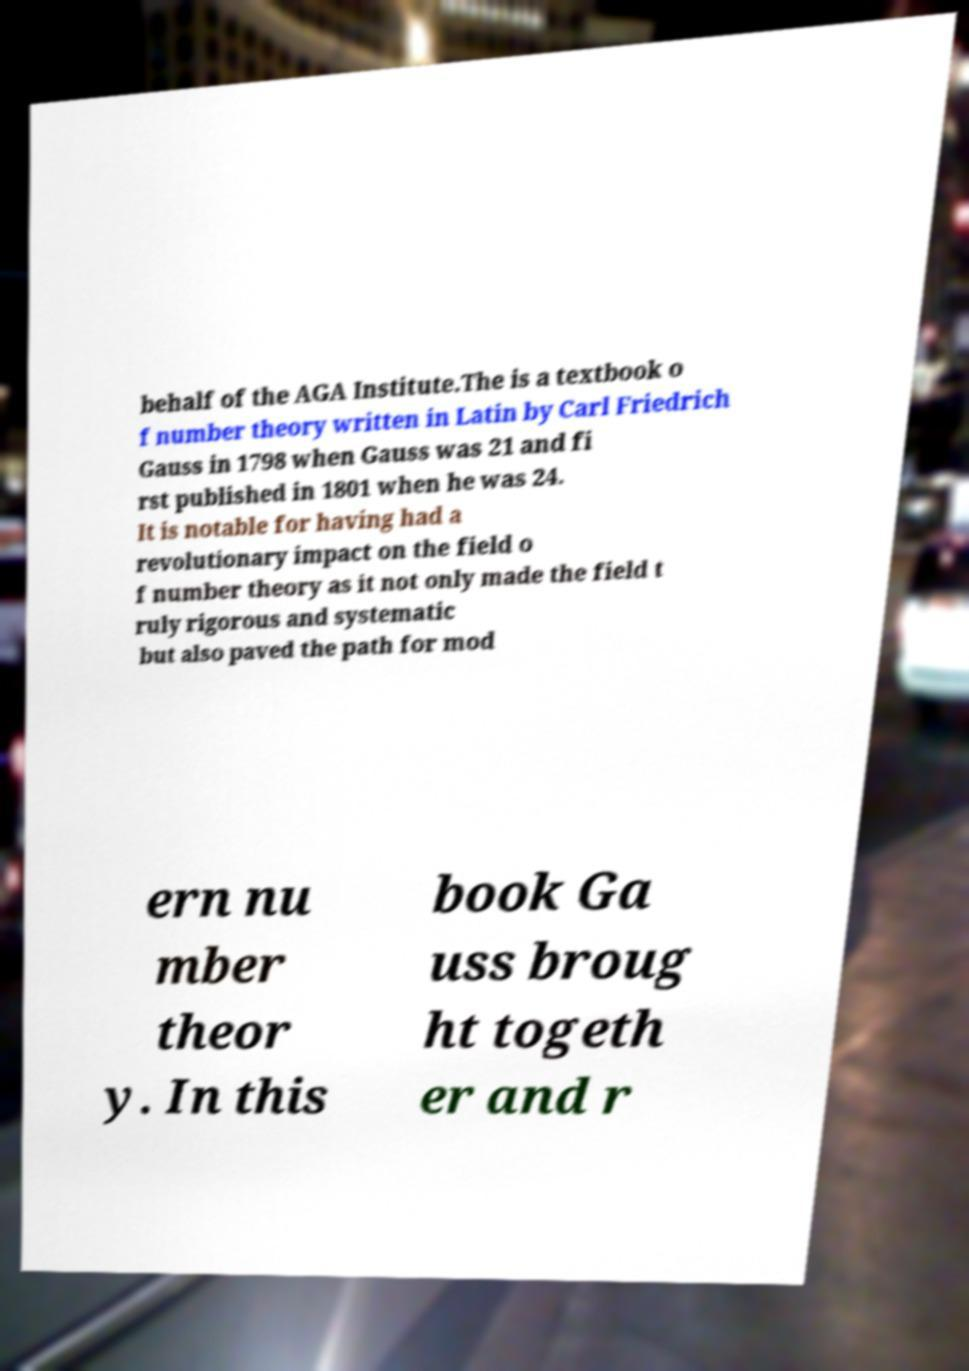Please identify and transcribe the text found in this image. behalf of the AGA Institute.The is a textbook o f number theory written in Latin by Carl Friedrich Gauss in 1798 when Gauss was 21 and fi rst published in 1801 when he was 24. It is notable for having had a revolutionary impact on the field o f number theory as it not only made the field t ruly rigorous and systematic but also paved the path for mod ern nu mber theor y. In this book Ga uss broug ht togeth er and r 